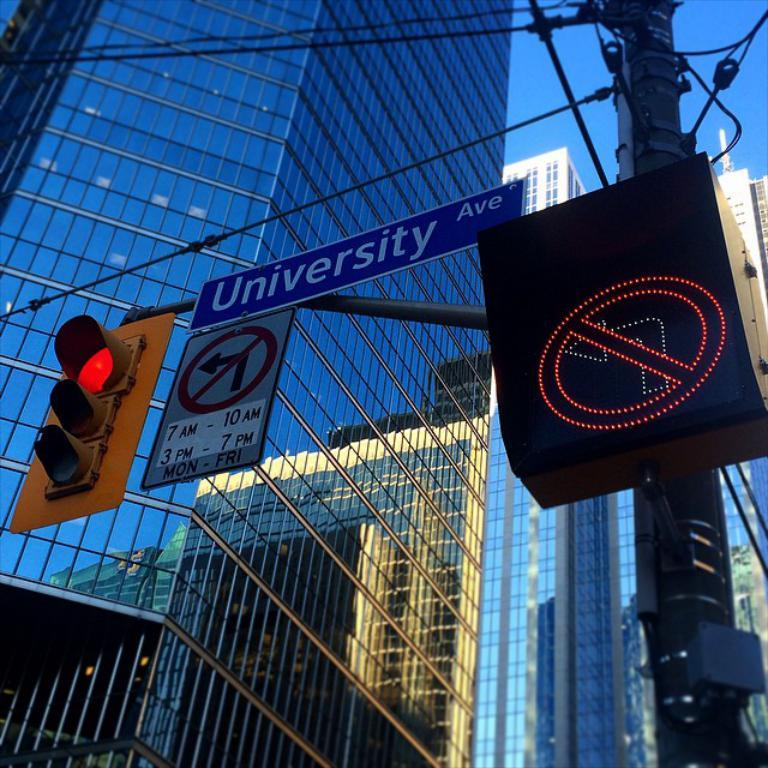What type of structures can be seen in the image? There are buildings in the image. What other objects can be seen in the image besides the buildings? There is a utility pole, a signal, and boards with text in the image. What is visible in the background of the image? The sky is visible in the background of the image. Can you see any cobwebs on the utility pole in the image? There is no mention of cobwebs in the image, so we cannot determine if any are present. What type of credit is being offered on the boards with text in the image? There is no information about credit being offered on the boards with text in the image. 